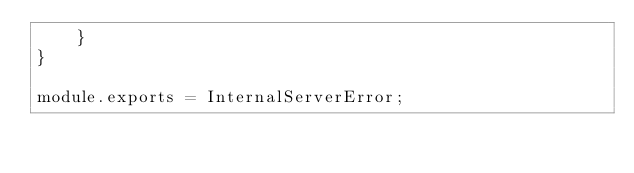Convert code to text. <code><loc_0><loc_0><loc_500><loc_500><_JavaScript_>    }
}

module.exports = InternalServerError;
</code> 